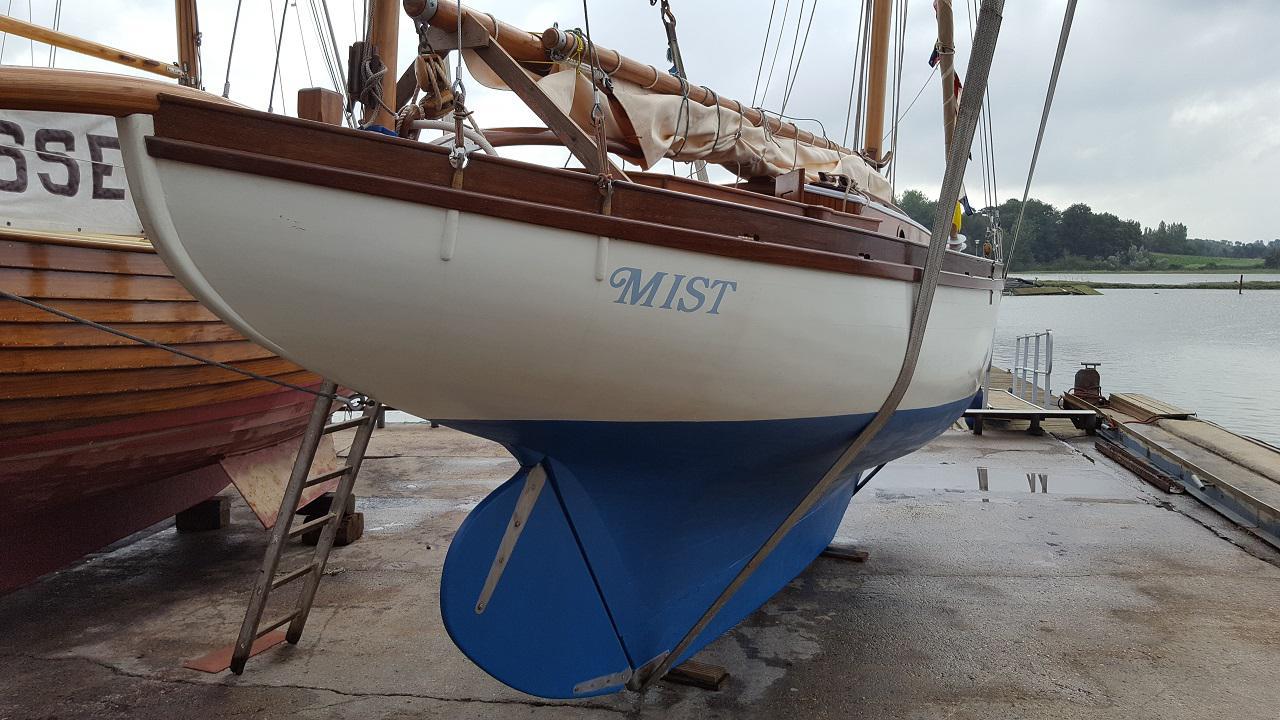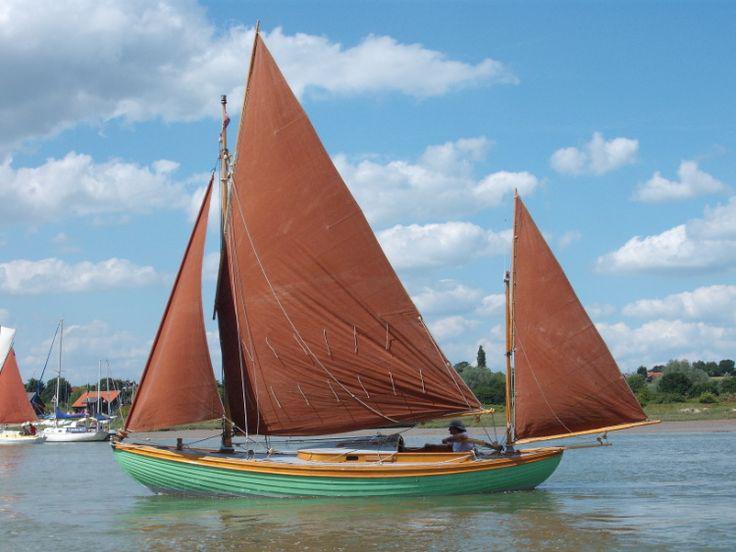The first image is the image on the left, the second image is the image on the right. Considering the images on both sides, is "There is a docked boat in the water whos sail is not deployed." valid? Answer yes or no. No. The first image is the image on the left, the second image is the image on the right. Considering the images on both sides, is "An image shows a white-sailed boat creating white spray as it moves through the water." valid? Answer yes or no. No. 